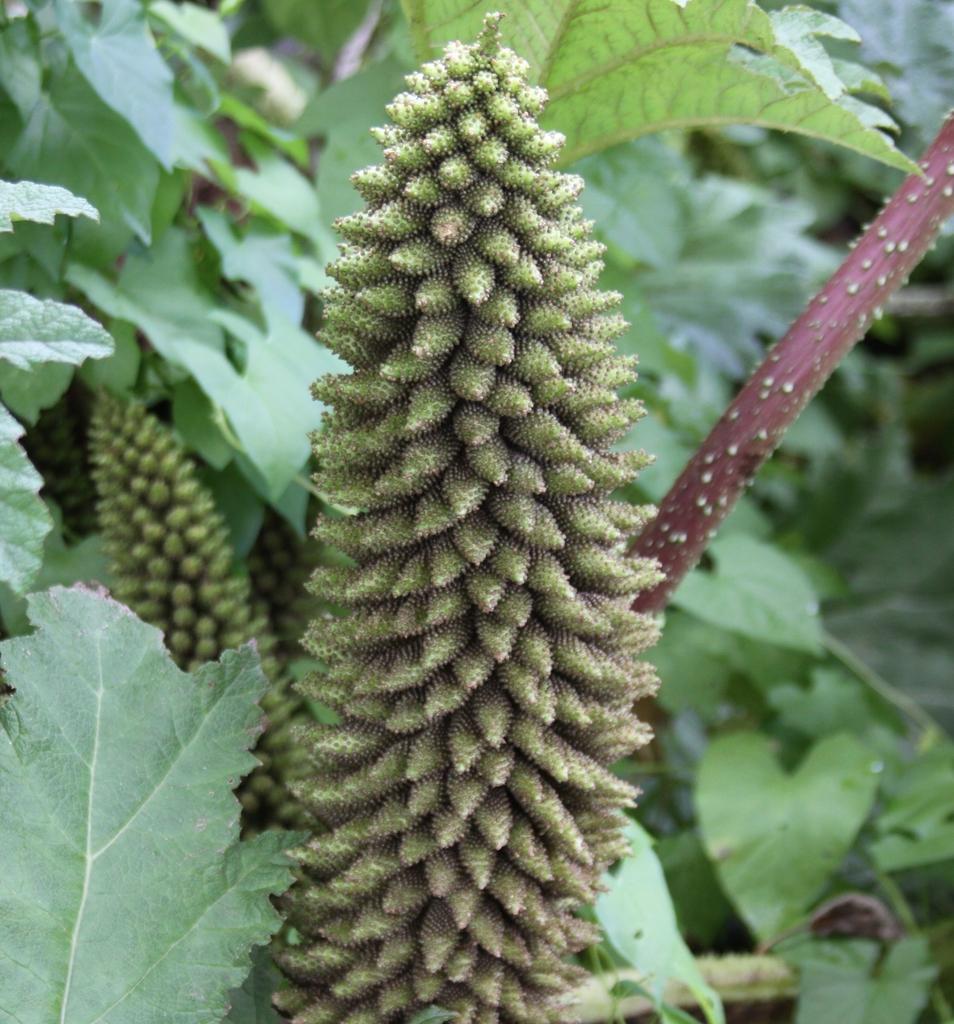Please provide a concise description of this image. In this image we can see plants with flowers. 